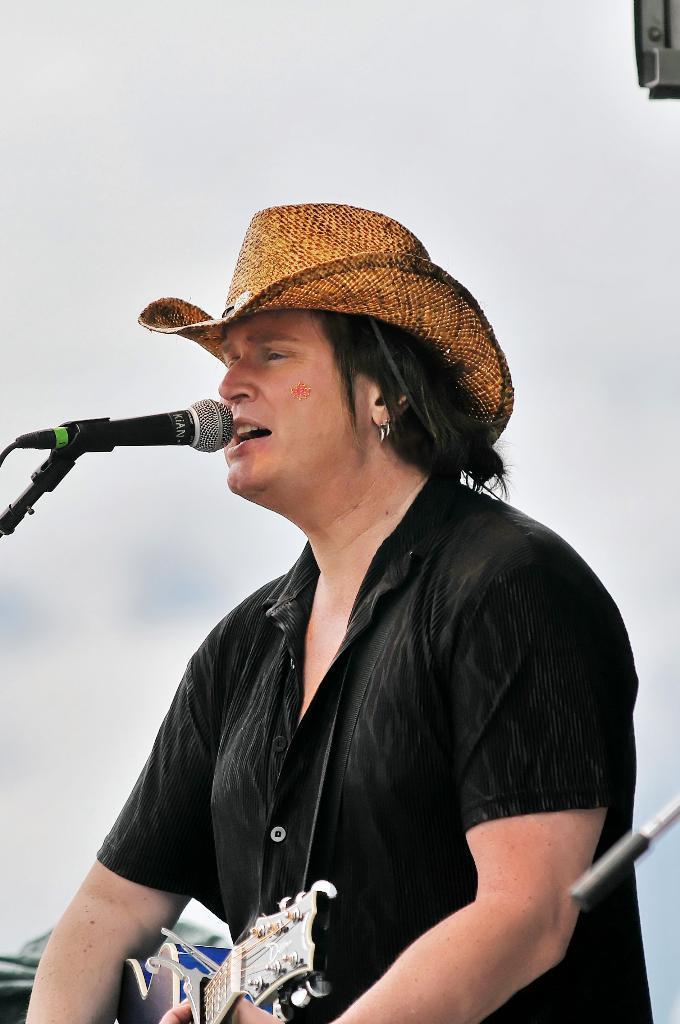How would you summarize this image in a sentence or two? In this image we can see a person wearing a black shirt and hat, holding a guitar. In front of this person there is a mike. In the background there is a wall. 